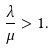Convert formula to latex. <formula><loc_0><loc_0><loc_500><loc_500>\frac { \lambda } { \mu } > 1 .</formula> 